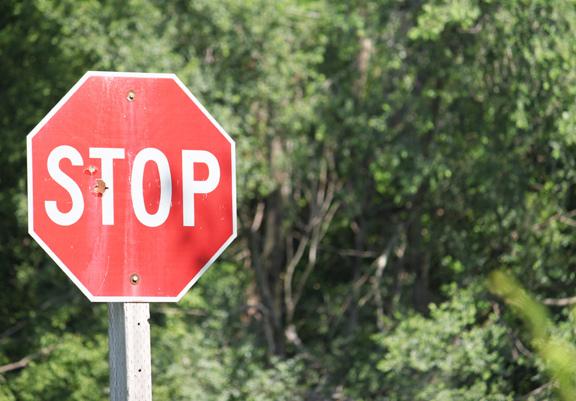Does this sign mean you should drive through without stopping?
Be succinct. No. What color is the stop sign?
Keep it brief. Red. What colors are the signs?
Give a very brief answer. Red. Is there writing under the word stop?
Quick response, please. No. What shape is this sign?
Quick response, please. Octagon. 